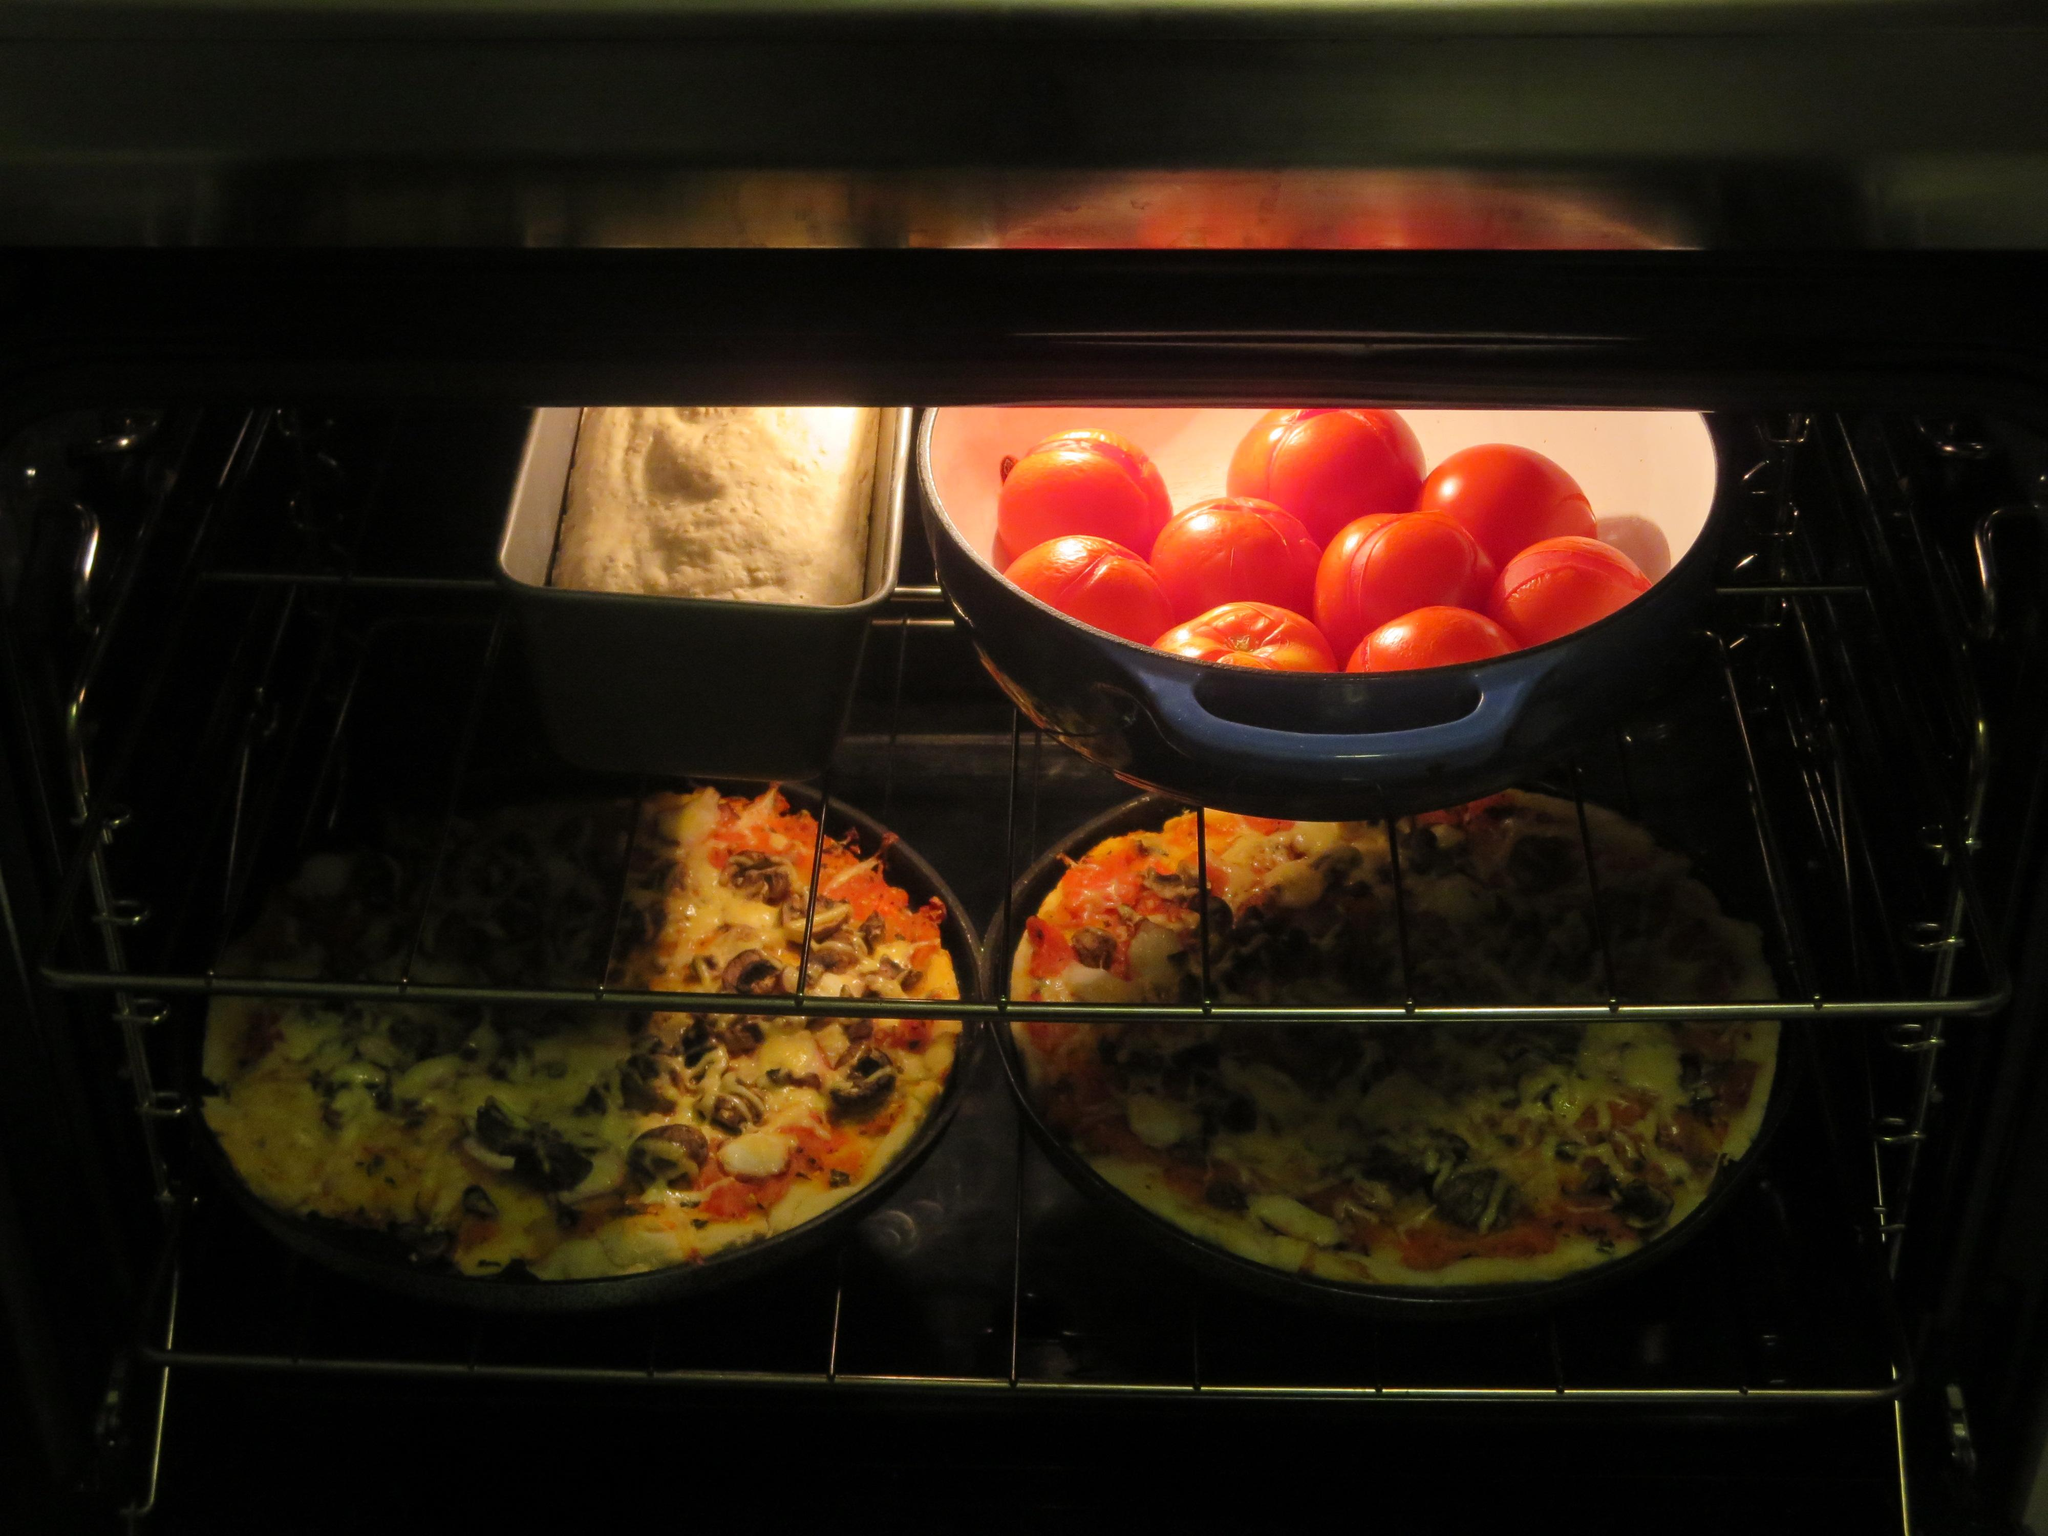What types of food items can be seen in the image? There are different kinds of food items in the image. Where are the food items located in the image? The food items are placed in a microwave. What type of bread is being used to spread butter in the image? There is no bread or butter present in the image; it only shows food items placed in a microwave. What emotion can be seen on the food items in the image? Food items do not have emotions, so it is not possible to determine any feelings or emotions from the image. 